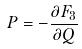Convert formula to latex. <formula><loc_0><loc_0><loc_500><loc_500>P = - \frac { \partial F _ { 3 } } { \partial Q }</formula> 